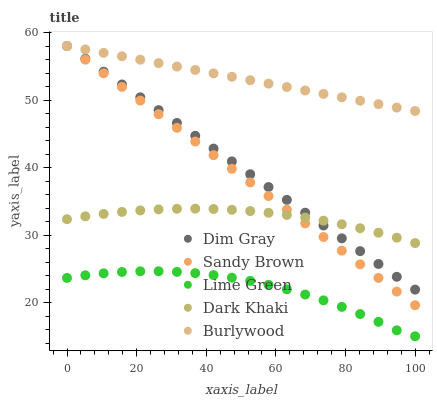Does Lime Green have the minimum area under the curve?
Answer yes or no. Yes. Does Burlywood have the maximum area under the curve?
Answer yes or no. Yes. Does Dim Gray have the minimum area under the curve?
Answer yes or no. No. Does Dim Gray have the maximum area under the curve?
Answer yes or no. No. Is Sandy Brown the smoothest?
Answer yes or no. Yes. Is Lime Green the roughest?
Answer yes or no. Yes. Is Dim Gray the smoothest?
Answer yes or no. No. Is Dim Gray the roughest?
Answer yes or no. No. Does Lime Green have the lowest value?
Answer yes or no. Yes. Does Dim Gray have the lowest value?
Answer yes or no. No. Does Burlywood have the highest value?
Answer yes or no. Yes. Does Lime Green have the highest value?
Answer yes or no. No. Is Lime Green less than Burlywood?
Answer yes or no. Yes. Is Burlywood greater than Lime Green?
Answer yes or no. Yes. Does Sandy Brown intersect Dark Khaki?
Answer yes or no. Yes. Is Sandy Brown less than Dark Khaki?
Answer yes or no. No. Is Sandy Brown greater than Dark Khaki?
Answer yes or no. No. Does Lime Green intersect Burlywood?
Answer yes or no. No. 